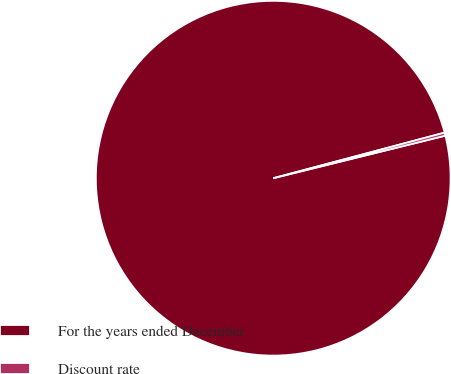<chart> <loc_0><loc_0><loc_500><loc_500><pie_chart><fcel>For the years ended December<fcel>Discount rate<nl><fcel>99.72%<fcel>0.28%<nl></chart> 